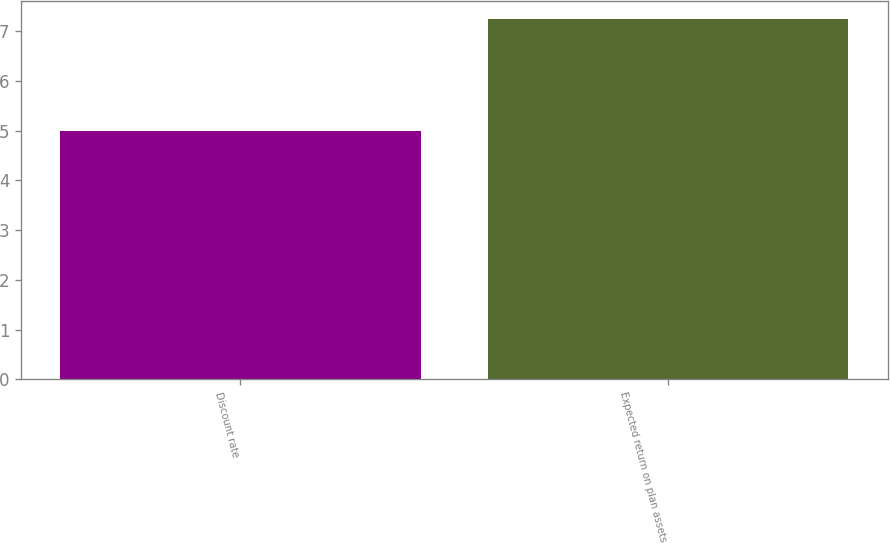Convert chart. <chart><loc_0><loc_0><loc_500><loc_500><bar_chart><fcel>Discount rate<fcel>Expected return on plan assets<nl><fcel>5<fcel>7.25<nl></chart> 